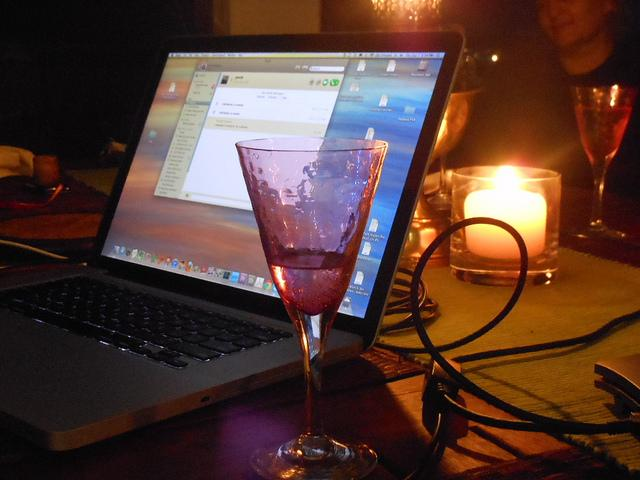What country most frequently uses wine glasses this shape? france 